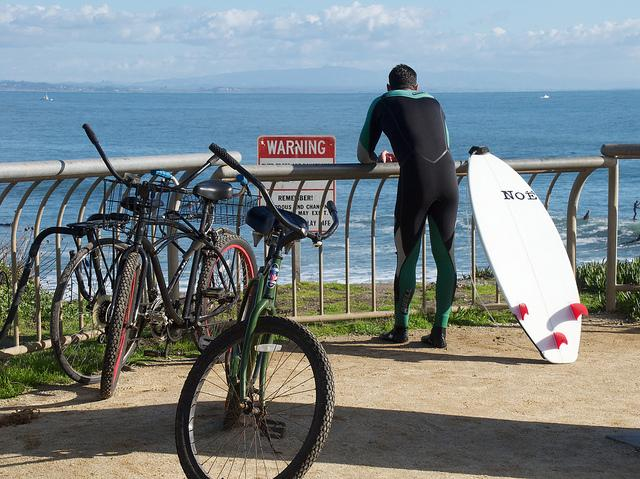What kind of surfboard it is?

Choices:
A) fish
B) spin
C) short board
D) fun short board 